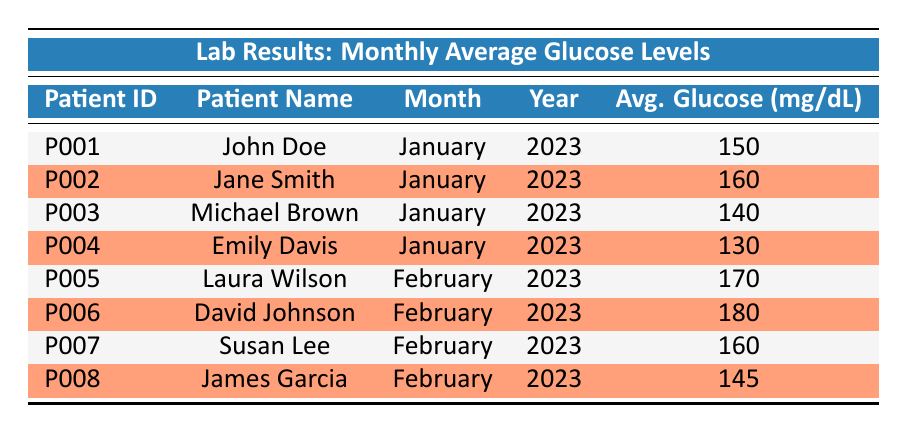What is the average glucose level for John Doe? From the table, John Doe's average glucose level is listed under his specific entry, which shows 150 mg/dL.
Answer: 150 mg/dL Which patient had the highest average glucose level in February? By checking the entries for February, David Johnson has the highest glucose level of 180 mg/dL among the values listed (170, 180, 160, and 145).
Answer: David Johnson What is the difference between the highest and lowest average glucose levels in January? In January, the highest glucose level is 160 mg/dL (Jane Smith) and the lowest is 130 mg/dL (Emily Davis). The difference is calculated as 160 - 130 = 30 mg/dL.
Answer: 30 mg/dL Are there any patients with an average glucose level above 160 mg/dL? When examining the table, we see that both Jane Smith and David Johnson had levels above 160 mg/dL (Jane: 160 in January, David: 180 in February).
Answer: Yes What is the sum of average glucose levels for all patients in January? The average glucose levels for January are 150, 160, 140, and 130 mg/dL. Summing these values: 150 + 160 + 140 + 130 = 580 mg/dL. The total for January is thus 580 mg/dL.
Answer: 580 mg/dL Which month's average glucose levels show a patient with the lowest reading? In February, the lowest average glucose level reported is 145 mg/dL from James Garcia. Examining both months shows January’s lowest is 130 mg/dL from Emily Davis, making February’s lower level significant.
Answer: February What is the average glucose level across all patients listed? The glucose levels are 150, 160, 140, 130, 170, 180, 160, and 145 mg/dL. First, summing these gives 1,125 mg/dL. Since there are 8 patients, the average is calculated as 1,125 / 8 = 140.625 mg/dL, which rounds to 141 mg/dL.
Answer: 141 mg/dL What percentage of the patients have an average glucose level below 150 mg/dL? Among the 8 patients, there are 3 with levels below 150 mg/dL (Michael Brown at 140, Emily Davis at 130). To find the percentage, (3 / 8) * 100 = 37.5%.
Answer: 37.5% Which patient names start with the letter "J"? Checking through the patient names, both John Doe and Jane Smith start with "J". Thus, there are two relevant entries.
Answer: John Doe, Jane Smith 